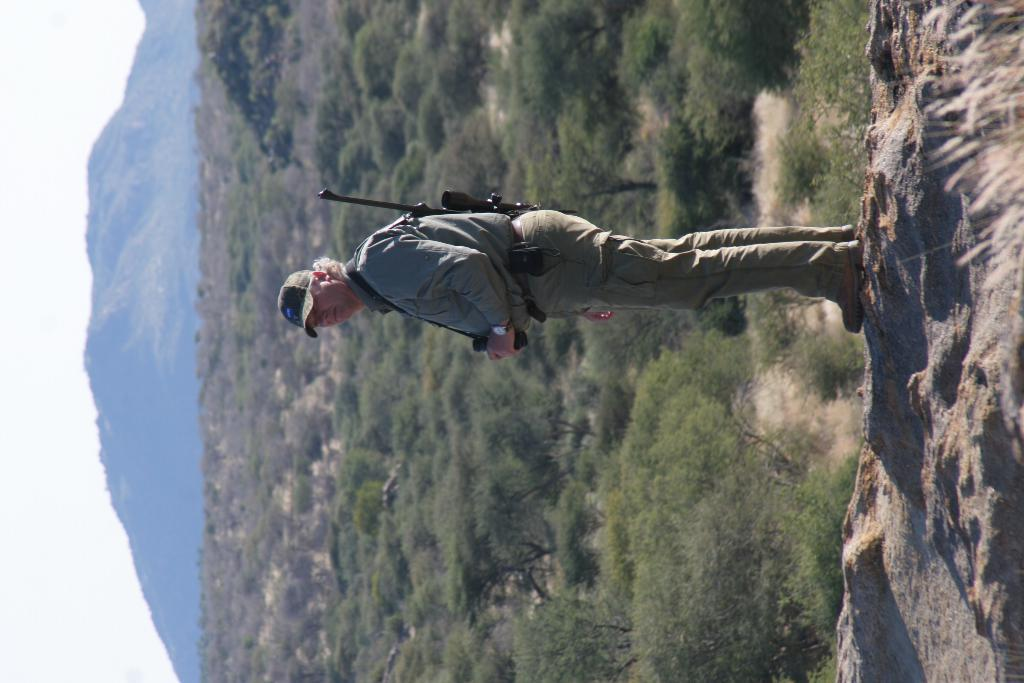What is the main subject of the image? There is a person in the image. What is the person holding in the image? The person is holding an object. Can you describe the object the person is holding? The person is carrying a gun. What type of natural environment is visible in the image? There are trees and mountains in the image. What is visible in the sky in the image? The sky is visible in the image. What type of insurance policy is the person discussing with the snake in the image? There is no snake present in the image, and therefore no discussion about insurance policies can be observed. 